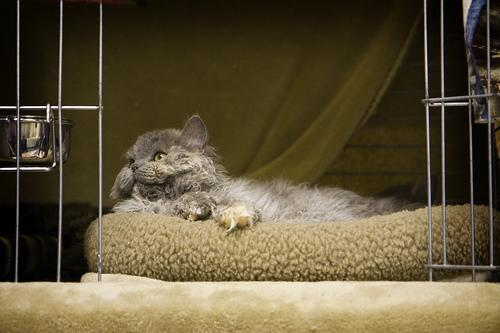What type of animal is in this cage? Please explain your reasoning. domestic. This is a house cat 